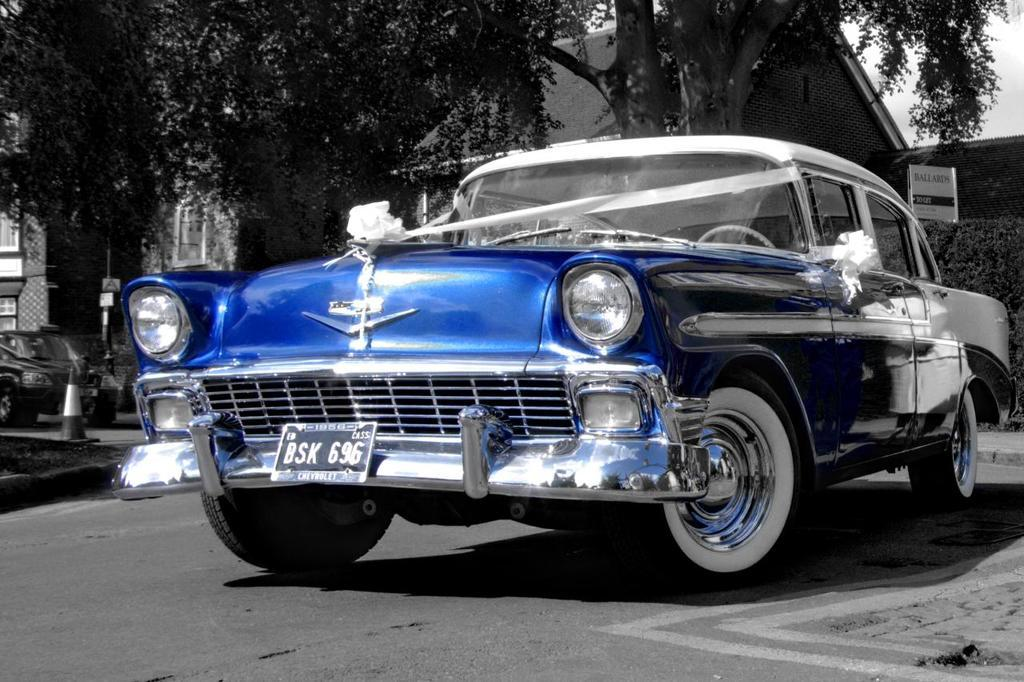What type of motor vehicle can be seen on the road in the image? There is a motor vehicle on the road in the image, but the specific type is not mentioned. What structures are visible in the image? There are buildings in the image. What objects are present to guide or warn drivers in the image? Traffic conesfic cones are present in the image. What type of signs are visible in the image that provide information or instructions? Information boards are visible in the image. What type of vegetation is present in the image? Bushes and trees are present in the image. What part of the natural environment is visible in the image? The sky is visible in the image. Can you tell me how many vessels are visible in the image? There are no vessels present in the image; it features a motor vehicle on the road, buildings, traffic cones, information boards, bushes, trees, and the sky. What type of swing can be seen in the image? There is no swing present in the image. 